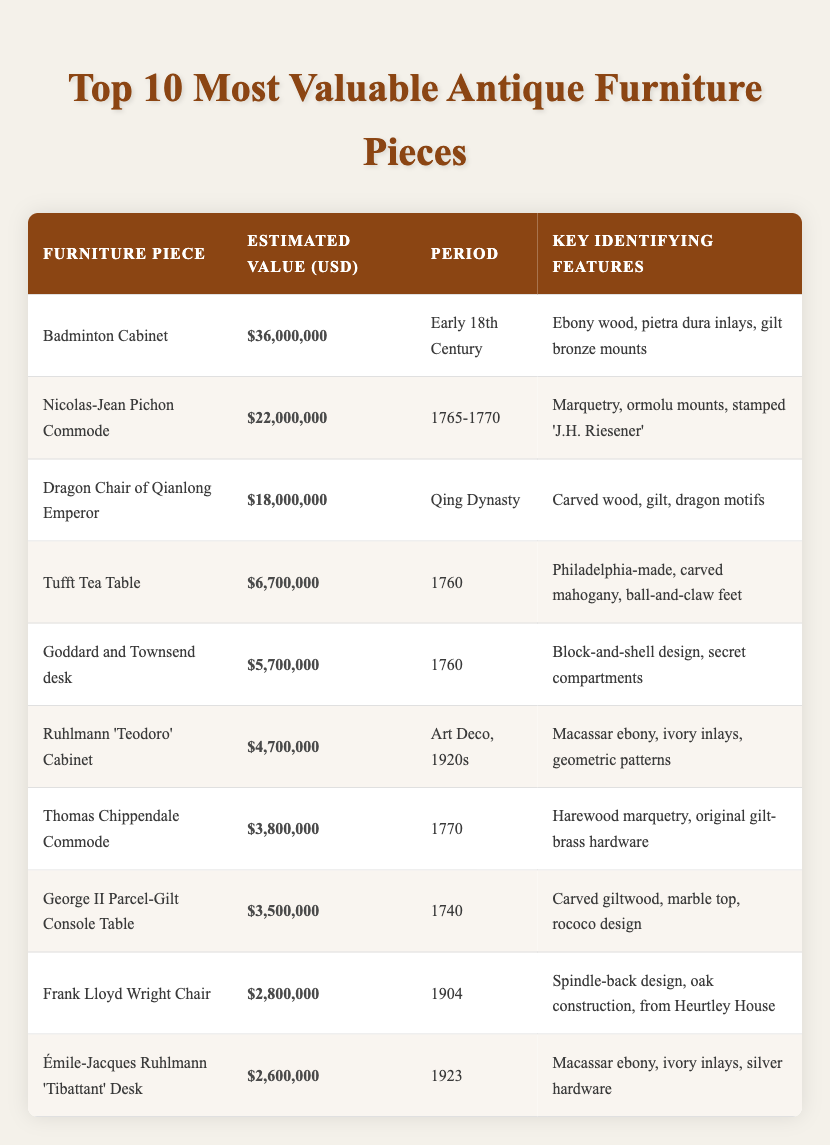What is the estimated value of the Badminton Cabinet? The value is given directly in the table under the "Estimated Value (USD)" column for the Badminton Cabinet row, which states $36,000,000.
Answer: $36,000,000 Which furniture piece is from the Qing Dynasty? The Dragon Chair of Qianlong Emperor is specifically categorized under the "Period" column as being from the Qing Dynasty.
Answer: Dragon Chair of Qianlong Emperor How much is the Nicolas-Jean Pichon Commode worth? The table shows the estimated value for the Nicolas-Jean Pichon Commode, listed under the "Estimated Value (USD)" as $22,000,000.
Answer: $22,000,000 True or False: The Ruhlmann 'Teodoro' Cabinet has a value greater than $5 million. The estimated value of the Ruhlmann 'Teodoro' Cabinet is $4,700,000, which is less than $5 million, making this statement false.
Answer: False What is the average estimated value of the top three furniture pieces? The top three valuable pieces are Badminton Cabinet ($36,000,000), Nicolas-Jean Pichon Commode ($22,000,000), and Dragon Chair of Qianlong Emperor ($18,000,000). Adding these gives: 36 + 22 + 18 = 76 million. Dividing by 3 provides the average: 76/3 = $25,333,333.33.
Answer: $25,333,333.33 Which furniture piece has the earliest date among those listed? Comparing the "Period" column, the earliest piece is the Badminton Cabinet, dated Early 18th Century.
Answer: Badminton Cabinet Is there a piece from the Art Deco period in the list? The Ruhlmann 'Teodoro' Cabinet is listed under the "Period" column as being from the Art Deco period, confirming there is at least one piece from this style.
Answer: Yes What is the total estimated value of furniture pieces from the 1760s? The pieces from the 1760s are the Nicolas-Jean Pichon Commode ($22,000,000) and the Goddard and Townsend desk ($5,700,000). Summing these values gives: $22,000,000 + $5,700,000 = $27,700,000.
Answer: $27,700,000 